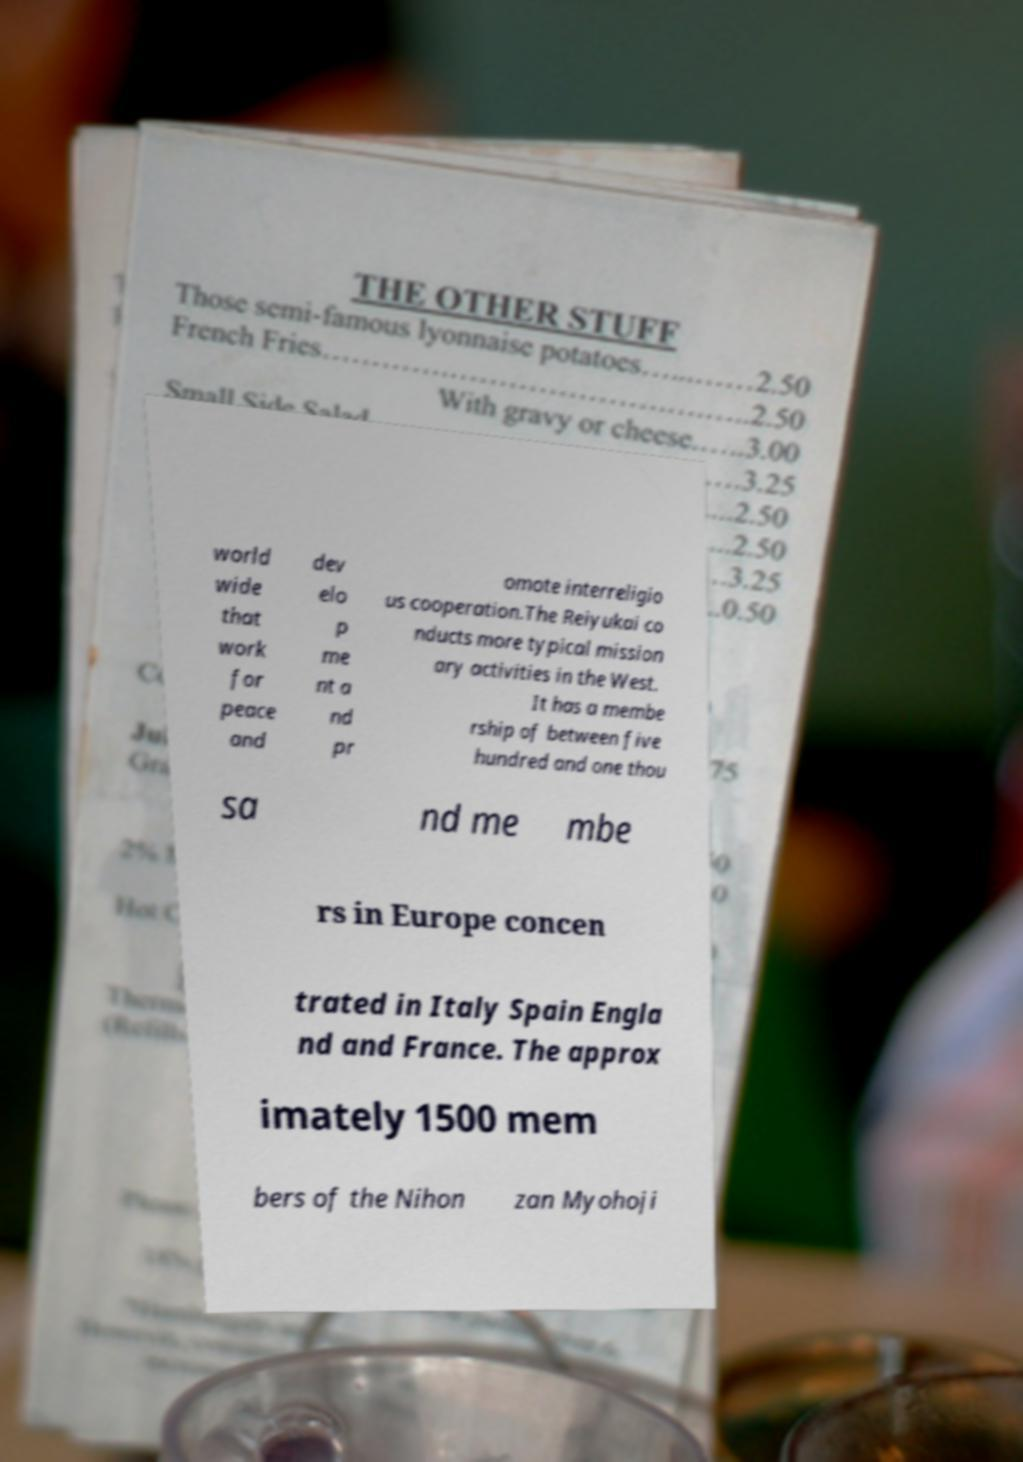Could you extract and type out the text from this image? world wide that work for peace and dev elo p me nt a nd pr omote interreligio us cooperation.The Reiyukai co nducts more typical mission ary activities in the West. It has a membe rship of between five hundred and one thou sa nd me mbe rs in Europe concen trated in Italy Spain Engla nd and France. The approx imately 1500 mem bers of the Nihon zan Myohoji 